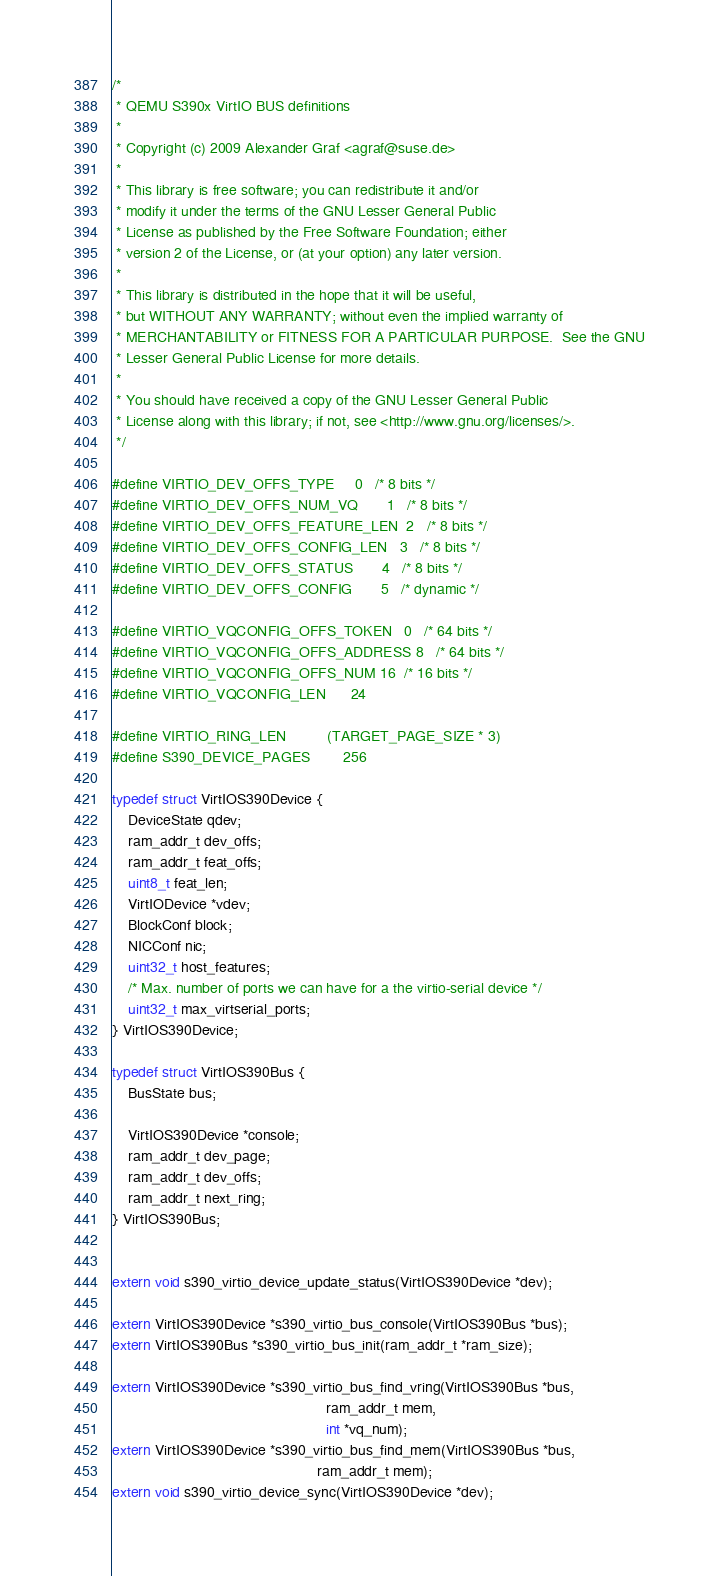<code> <loc_0><loc_0><loc_500><loc_500><_C_>/*
 * QEMU S390x VirtIO BUS definitions
 *
 * Copyright (c) 2009 Alexander Graf <agraf@suse.de>
 *
 * This library is free software; you can redistribute it and/or
 * modify it under the terms of the GNU Lesser General Public
 * License as published by the Free Software Foundation; either
 * version 2 of the License, or (at your option) any later version.
 *
 * This library is distributed in the hope that it will be useful,
 * but WITHOUT ANY WARRANTY; without even the implied warranty of
 * MERCHANTABILITY or FITNESS FOR A PARTICULAR PURPOSE.  See the GNU
 * Lesser General Public License for more details.
 *
 * You should have received a copy of the GNU Lesser General Public
 * License along with this library; if not, see <http://www.gnu.org/licenses/>.
 */

#define VIRTIO_DEV_OFFS_TYPE		0	/* 8 bits */
#define VIRTIO_DEV_OFFS_NUM_VQ		1	/* 8 bits */
#define VIRTIO_DEV_OFFS_FEATURE_LEN	2	/* 8 bits */
#define VIRTIO_DEV_OFFS_CONFIG_LEN	3	/* 8 bits */
#define VIRTIO_DEV_OFFS_STATUS		4	/* 8 bits */
#define VIRTIO_DEV_OFFS_CONFIG		5	/* dynamic */

#define VIRTIO_VQCONFIG_OFFS_TOKEN	0	/* 64 bits */
#define VIRTIO_VQCONFIG_OFFS_ADDRESS	8	/* 64 bits */
#define VIRTIO_VQCONFIG_OFFS_NUM	16	/* 16 bits */
#define VIRTIO_VQCONFIG_LEN		24

#define VIRTIO_RING_LEN			(TARGET_PAGE_SIZE * 3)
#define S390_DEVICE_PAGES		256

typedef struct VirtIOS390Device {
    DeviceState qdev;
    ram_addr_t dev_offs;
    ram_addr_t feat_offs;
    uint8_t feat_len;
    VirtIODevice *vdev;
    BlockConf block;
    NICConf nic;
    uint32_t host_features;
    /* Max. number of ports we can have for a the virtio-serial device */
    uint32_t max_virtserial_ports;
} VirtIOS390Device;

typedef struct VirtIOS390Bus {
    BusState bus;

    VirtIOS390Device *console;
    ram_addr_t dev_page;
    ram_addr_t dev_offs;
    ram_addr_t next_ring;
} VirtIOS390Bus;


extern void s390_virtio_device_update_status(VirtIOS390Device *dev);

extern VirtIOS390Device *s390_virtio_bus_console(VirtIOS390Bus *bus);
extern VirtIOS390Bus *s390_virtio_bus_init(ram_addr_t *ram_size);

extern VirtIOS390Device *s390_virtio_bus_find_vring(VirtIOS390Bus *bus,
                                                    ram_addr_t mem,
                                                    int *vq_num);
extern VirtIOS390Device *s390_virtio_bus_find_mem(VirtIOS390Bus *bus,
                                                  ram_addr_t mem);
extern void s390_virtio_device_sync(VirtIOS390Device *dev);
</code> 